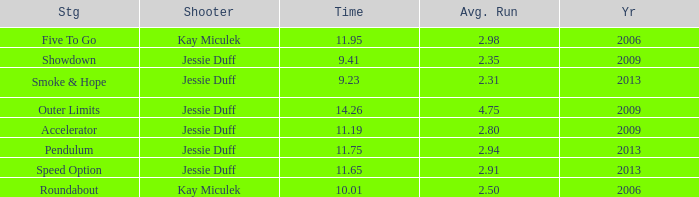Could you help me parse every detail presented in this table? {'header': ['Stg', 'Shooter', 'Time', 'Avg. Run', 'Yr'], 'rows': [['Five To Go', 'Kay Miculek', '11.95', '2.98', '2006'], ['Showdown', 'Jessie Duff', '9.41', '2.35', '2009'], ['Smoke & Hope', 'Jessie Duff', '9.23', '2.31', '2013'], ['Outer Limits', 'Jessie Duff', '14.26', '4.75', '2009'], ['Accelerator', 'Jessie Duff', '11.19', '2.80', '2009'], ['Pendulum', 'Jessie Duff', '11.75', '2.94', '2013'], ['Speed Option', 'Jessie Duff', '11.65', '2.91', '2013'], ['Roundabout', 'Kay Miculek', '10.01', '2.50', '2006']]} What is the total amount of time for years prior to 2013 when speed option is the stage? None. 